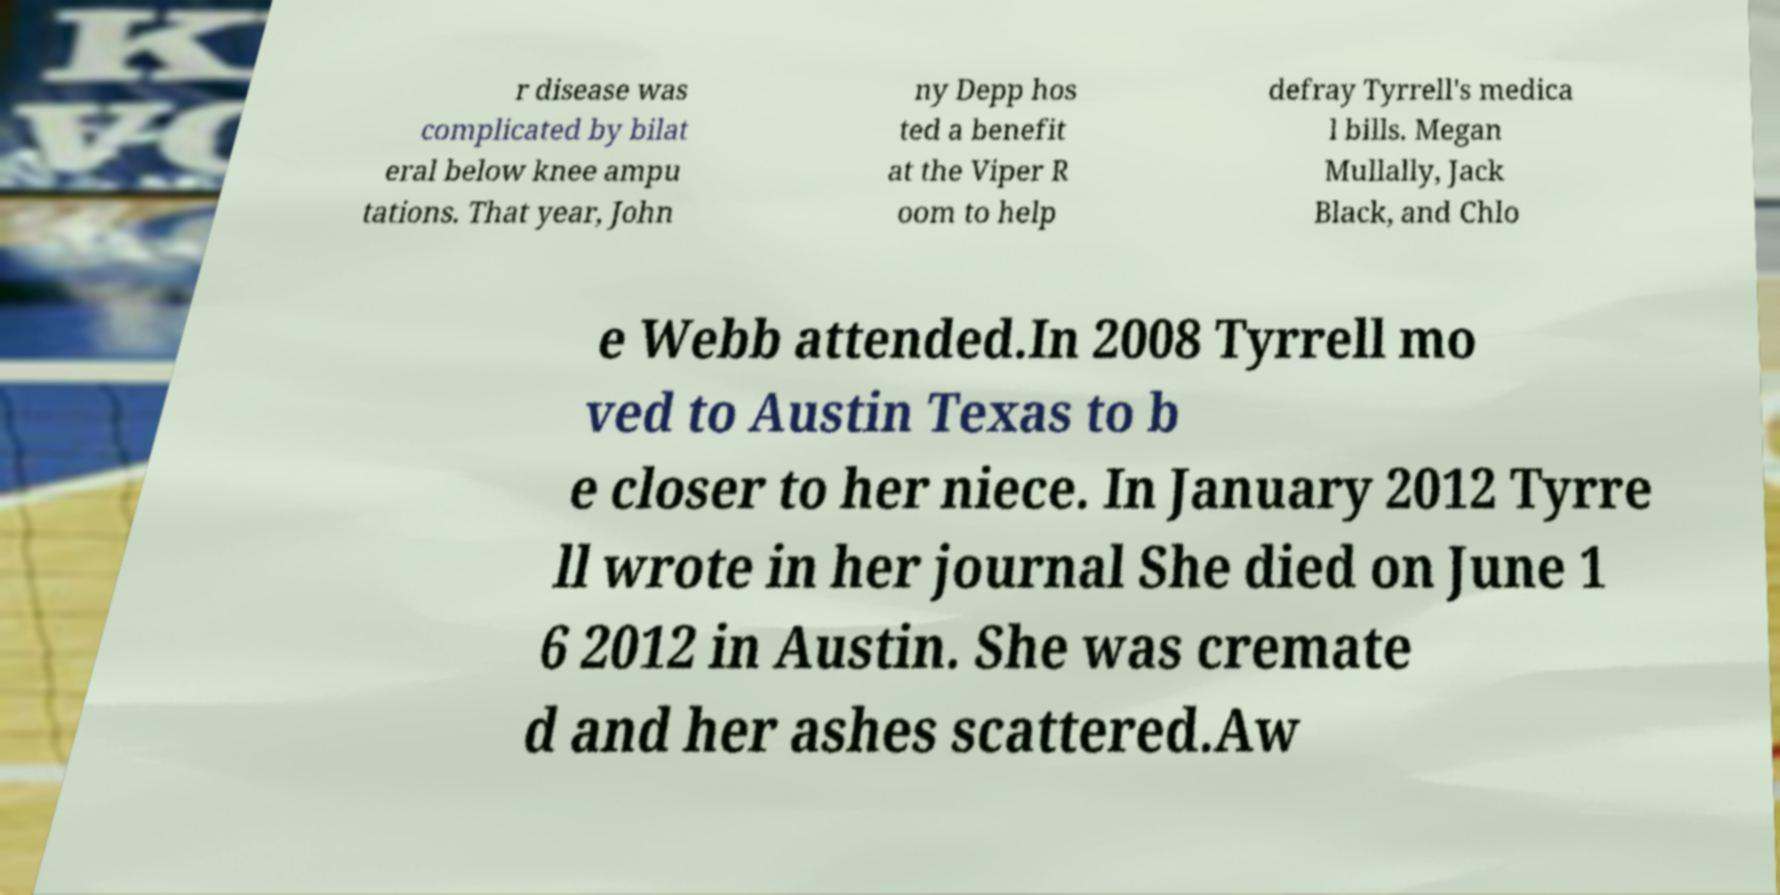For documentation purposes, I need the text within this image transcribed. Could you provide that? r disease was complicated by bilat eral below knee ampu tations. That year, John ny Depp hos ted a benefit at the Viper R oom to help defray Tyrrell's medica l bills. Megan Mullally, Jack Black, and Chlo e Webb attended.In 2008 Tyrrell mo ved to Austin Texas to b e closer to her niece. In January 2012 Tyrre ll wrote in her journal She died on June 1 6 2012 in Austin. She was cremate d and her ashes scattered.Aw 